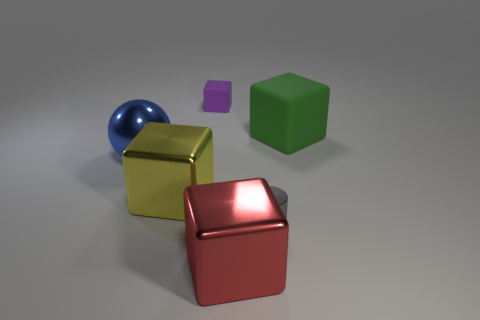If these objects were part of a game, what kind of game could it be? Should these objects be elements of a game, it's conceivable that they are components of a three-dimensional puzzle or logic game, where a player might have to arrange the items according to specific rules—such as sorting by size, color, or shape to achieve a determined goal. 